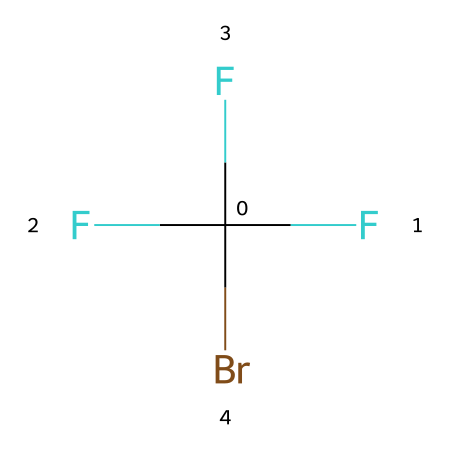What is the molecular formula of this compound? The SMILES representation shows three fluorine atoms (F), one bromine atom (Br), and one carbon atom (C), resulting in a molecular formula of CBrF3.
Answer: CBrF3 How many halogen atoms are present in this molecule? The molecule contains three fluorine atoms and one bromine atom, giving a total of four halogen atoms.
Answer: four What is the primary use of this chemical in fire-extinguishing systems? Compounds like this one, being halogenated hydrocarbons, are often used as fire-extinguishing agents because they interrupt combustion reactions.
Answer: extinguishing agent What type of bonding is expected in this compound? The presence of carbon, bromine, and fluorine in the structure indicates covalent bonding, as these atoms typically form covalent connections in organic and inorganic compounds.
Answer: covalent Which element contributes to the compound's fire suppression capability? The bromine atom is significant as it can assist in the inhibition of burning due to its ability to form radical species that react with free radicals in combustion.
Answer: bromine 